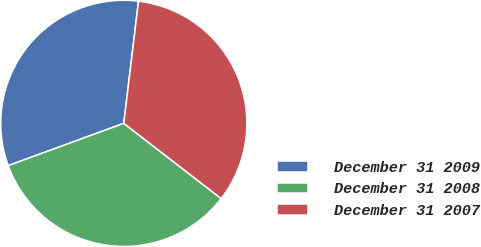<chart> <loc_0><loc_0><loc_500><loc_500><pie_chart><fcel>December 31 2009<fcel>December 31 2008<fcel>December 31 2007<nl><fcel>32.49%<fcel>33.95%<fcel>33.56%<nl></chart> 